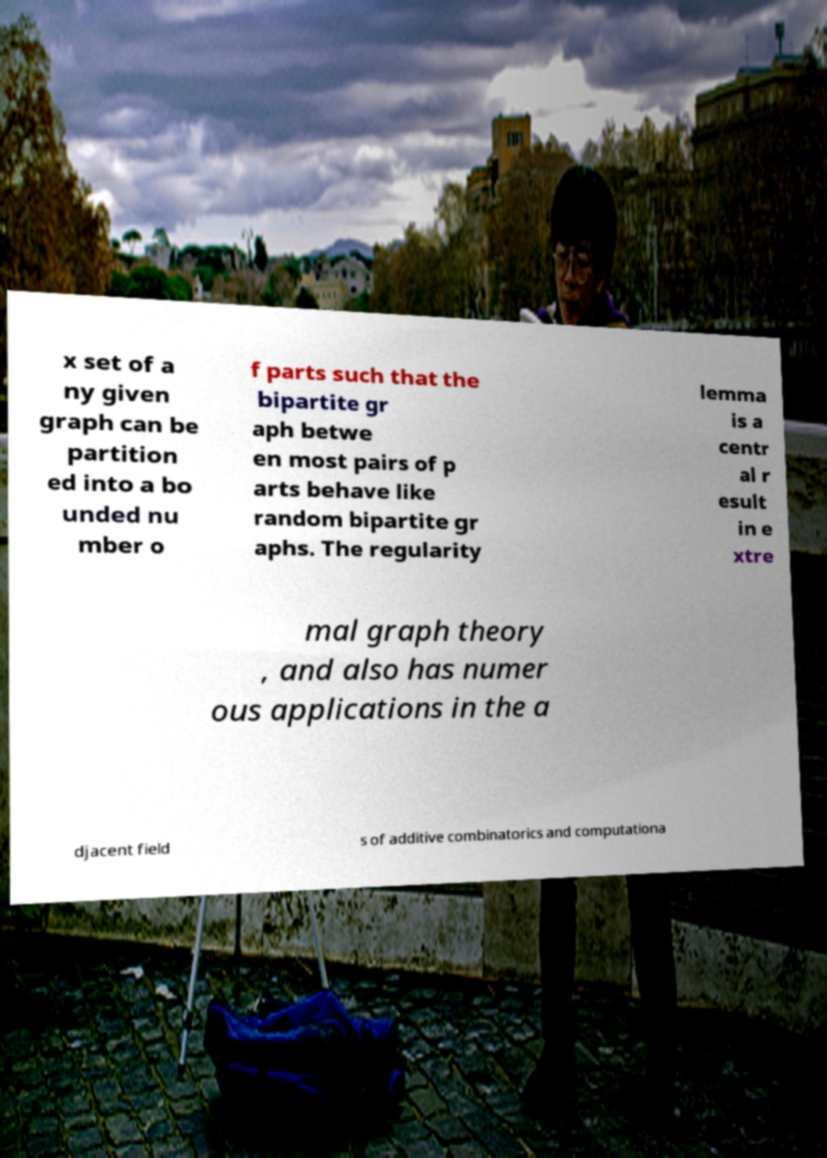Could you assist in decoding the text presented in this image and type it out clearly? x set of a ny given graph can be partition ed into a bo unded nu mber o f parts such that the bipartite gr aph betwe en most pairs of p arts behave like random bipartite gr aphs. The regularity lemma is a centr al r esult in e xtre mal graph theory , and also has numer ous applications in the a djacent field s of additive combinatorics and computationa 